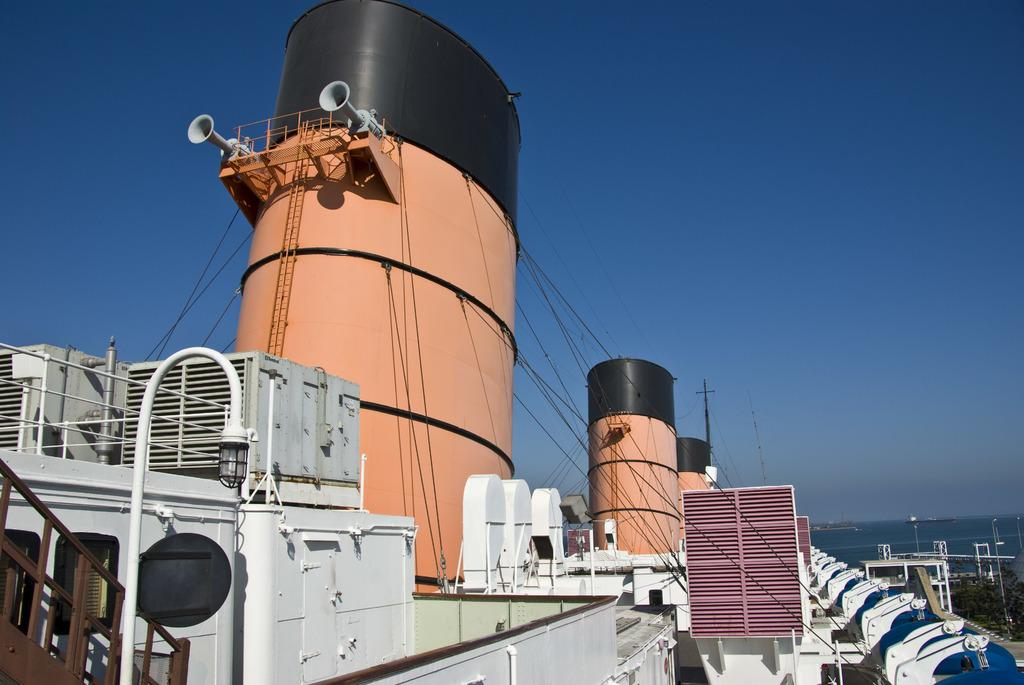What is the main subject of the image? The main subject of the image is a ship. What features can be seen on the ship? The ship has railings and stairs. Is there any source of light on the ship? Yes, there is a light on the ship. What can be seen in the background of the image? In the background, there is water, poles, and trees. What is visible at the top of the image? The sky is visible at the top of the image. What type of face can be seen on the ship's body in the image? There are no faces or bodies present on the ship in the image. What kind of lumber is being transported by the ship in the image? The image does not show any lumber being transported by the ship. 